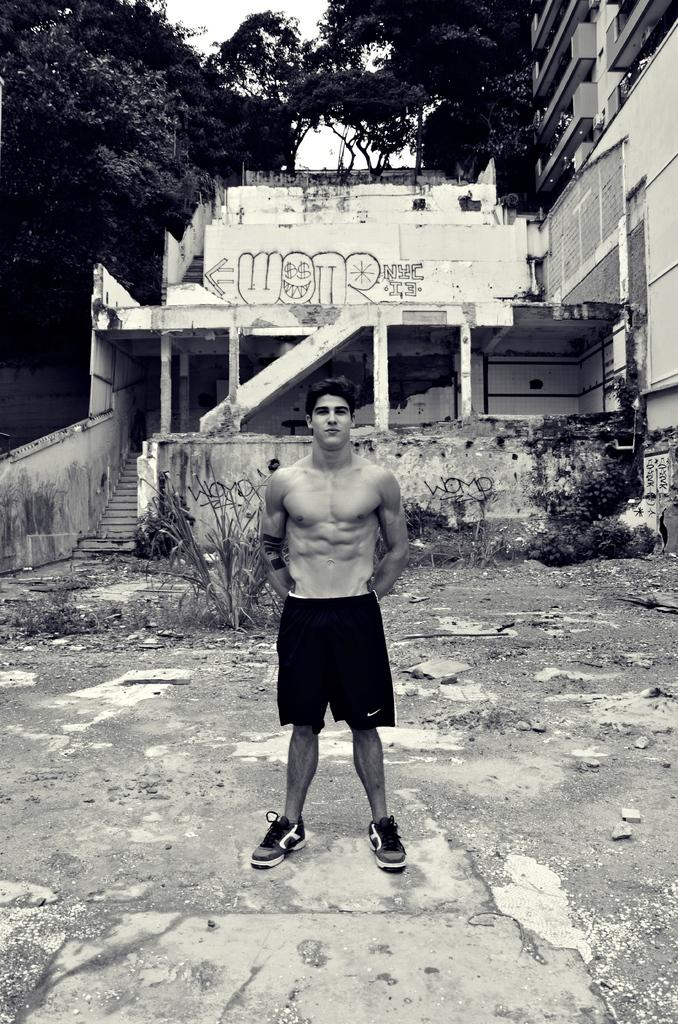What is the main subject in the image? There is a man standing in the image. What can be seen in the background of the image? There is a building, plants, trees, and the sky visible in the background of the image. What type of kettle is the servant using in the image? There is no servant or kettle present in the image. 